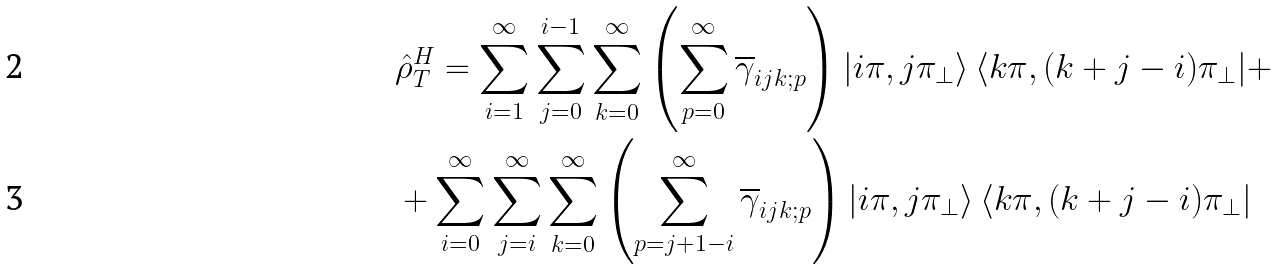Convert formula to latex. <formula><loc_0><loc_0><loc_500><loc_500>& \hat { \rho } ^ { H } _ { T } = \sum _ { i = 1 } ^ { \infty } \sum _ { j = 0 } ^ { i - 1 } \sum _ { k = 0 } ^ { \infty } \left ( \sum _ { p = 0 } ^ { \infty } \overline { \gamma } _ { i j k ; p } \right ) | i \pi , j \pi _ { \bot } \rangle \, \langle k \pi , ( k + j - i ) \pi _ { \bot } | + \\ & + \sum _ { i = 0 } ^ { \infty } \sum _ { j = i } ^ { \infty } \sum _ { k = 0 } ^ { \infty } \left ( \sum _ { p = j + 1 - i } ^ { \infty } \overline { \gamma } _ { i j k ; p } \right ) | i \pi , j \pi _ { \bot } \rangle \, \langle k \pi , ( k + j - i ) \pi _ { \bot } |</formula> 